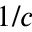Convert formula to latex. <formula><loc_0><loc_0><loc_500><loc_500>1 / c</formula> 